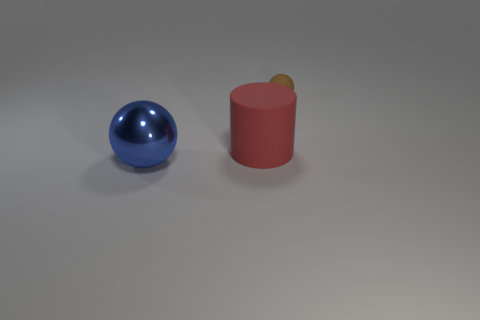Can you describe the size relationship between the yellow sphere and the other objects? Certainly. The yellow sphere perched atop the cylinder is significantly smaller in size compared to both the metal sphere and the cylinder. It appears to be roughly a quarter of the diameter of the metal sphere, indicating it's the smallest object in the scene in terms of both size and volume. 